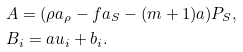Convert formula to latex. <formula><loc_0><loc_0><loc_500><loc_500>& A = ( \rho a _ { \rho } - f a _ { S } - ( m + 1 ) a ) P _ { S } , \\ & B _ { i } = a u _ { i } + b _ { i } .</formula> 